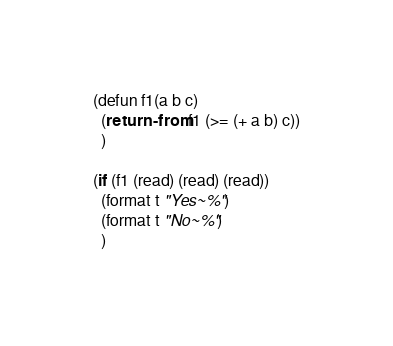<code> <loc_0><loc_0><loc_500><loc_500><_Lisp_>(defun f1(a b c)
  (return-from f1 (>= (+ a b) c))
  )

(if (f1 (read) (read) (read))
  (format t "Yes~%")
  (format t "No~%")
  )
</code> 